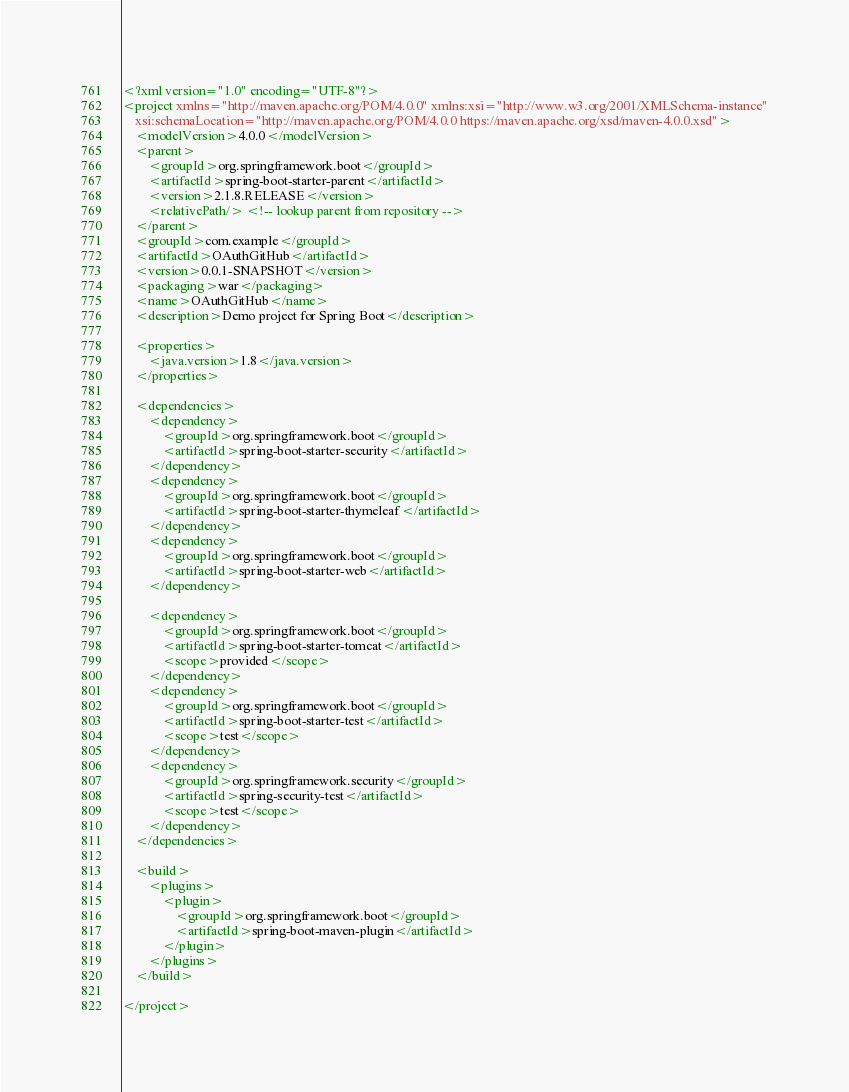<code> <loc_0><loc_0><loc_500><loc_500><_XML_><?xml version="1.0" encoding="UTF-8"?>
<project xmlns="http://maven.apache.org/POM/4.0.0" xmlns:xsi="http://www.w3.org/2001/XMLSchema-instance"
	xsi:schemaLocation="http://maven.apache.org/POM/4.0.0 https://maven.apache.org/xsd/maven-4.0.0.xsd">
	<modelVersion>4.0.0</modelVersion>
	<parent>
		<groupId>org.springframework.boot</groupId>
		<artifactId>spring-boot-starter-parent</artifactId>
		<version>2.1.8.RELEASE</version>
		<relativePath/> <!-- lookup parent from repository -->
	</parent>
	<groupId>com.example</groupId>
	<artifactId>OAuthGitHub</artifactId>
	<version>0.0.1-SNAPSHOT</version>
	<packaging>war</packaging>
	<name>OAuthGitHub</name>
	<description>Demo project for Spring Boot</description>

	<properties>
		<java.version>1.8</java.version>
	</properties>

	<dependencies>
		<dependency>
			<groupId>org.springframework.boot</groupId>
			<artifactId>spring-boot-starter-security</artifactId>
		</dependency>
		<dependency>
			<groupId>org.springframework.boot</groupId>
			<artifactId>spring-boot-starter-thymeleaf</artifactId>
		</dependency>
		<dependency>
			<groupId>org.springframework.boot</groupId>
			<artifactId>spring-boot-starter-web</artifactId>
		</dependency>

		<dependency>
			<groupId>org.springframework.boot</groupId>
			<artifactId>spring-boot-starter-tomcat</artifactId>
			<scope>provided</scope>
		</dependency>
		<dependency>
			<groupId>org.springframework.boot</groupId>
			<artifactId>spring-boot-starter-test</artifactId>
			<scope>test</scope>
		</dependency>
		<dependency>
			<groupId>org.springframework.security</groupId>
			<artifactId>spring-security-test</artifactId>
			<scope>test</scope>
		</dependency>
	</dependencies>

	<build>
		<plugins>
			<plugin>
				<groupId>org.springframework.boot</groupId>
				<artifactId>spring-boot-maven-plugin</artifactId>
			</plugin>
		</plugins>
	</build>

</project>
</code> 